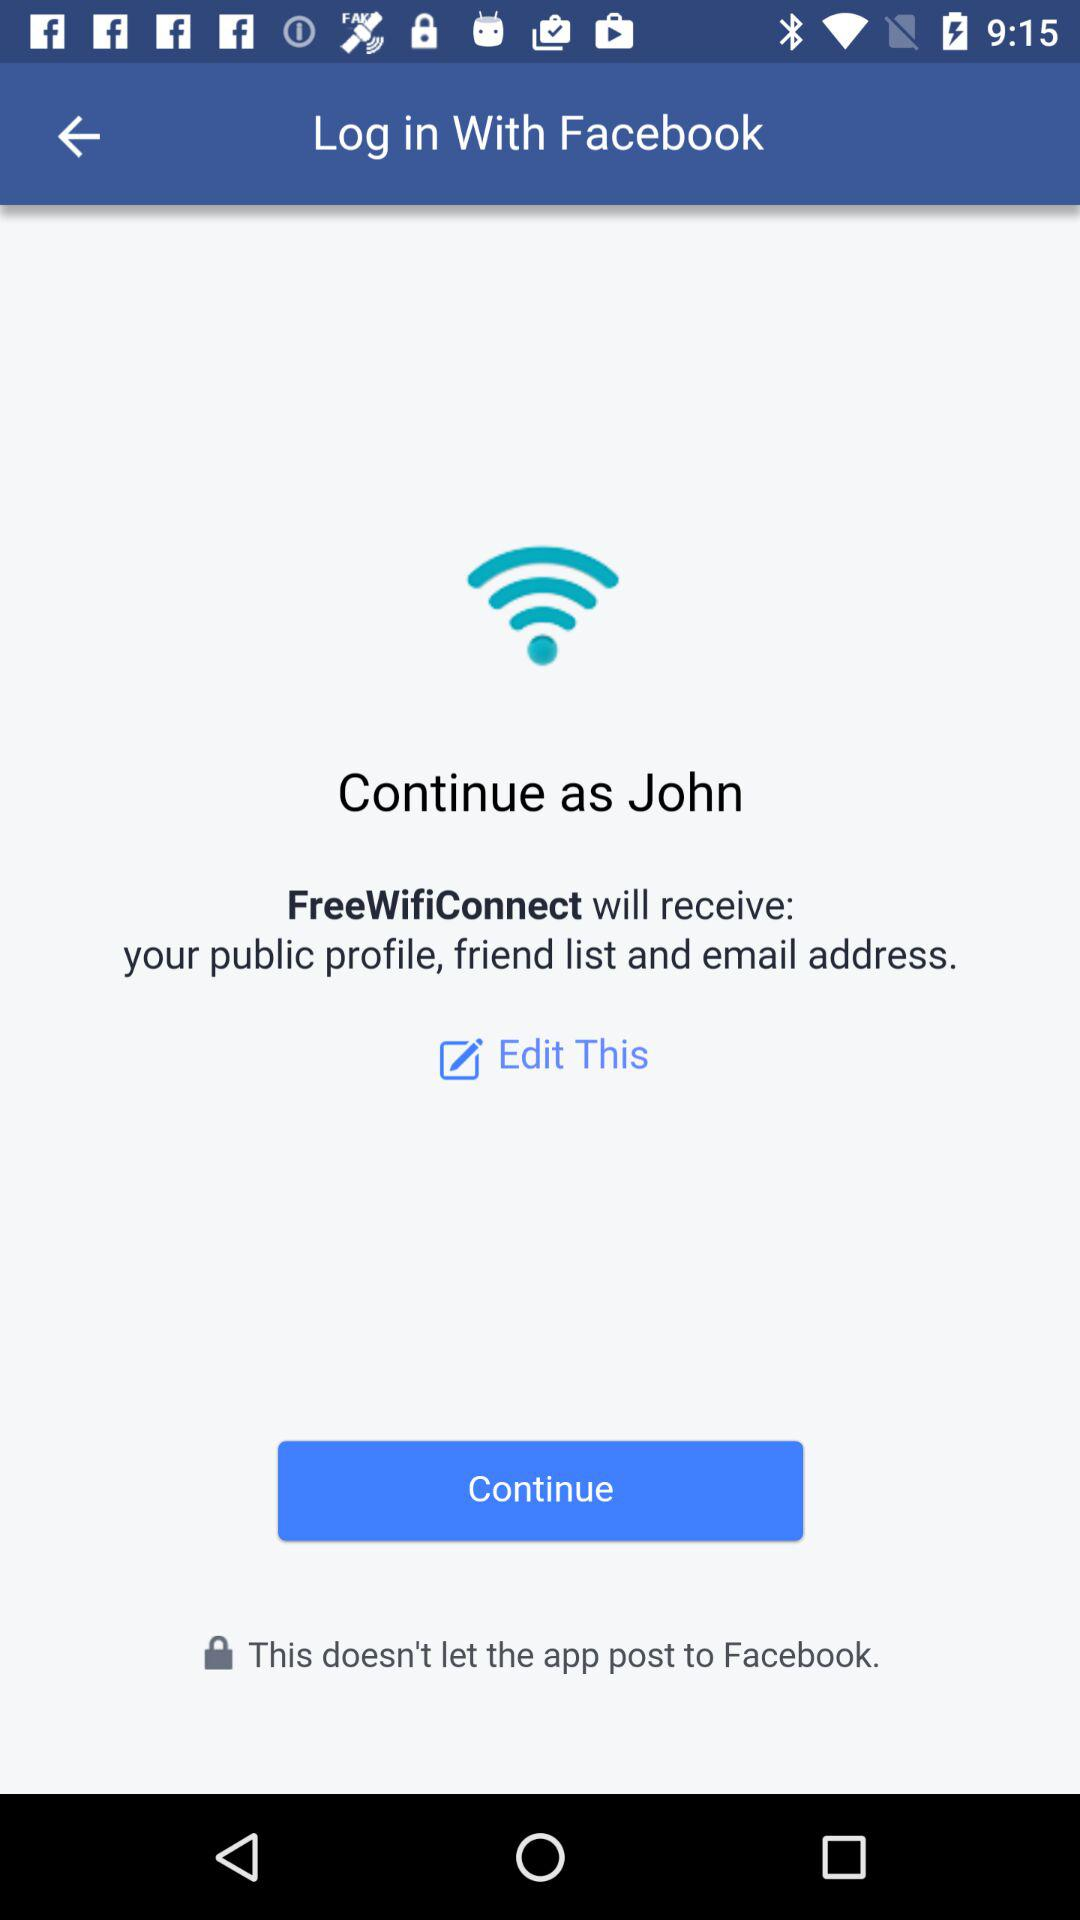What is the user name? The user name is John. 